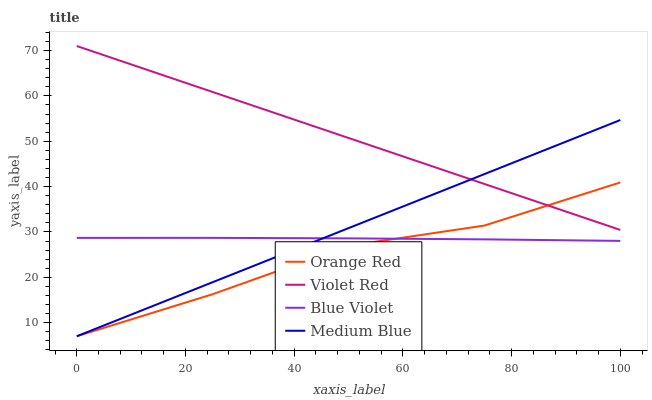Does Orange Red have the minimum area under the curve?
Answer yes or no. Yes. Does Violet Red have the maximum area under the curve?
Answer yes or no. Yes. Does Medium Blue have the minimum area under the curve?
Answer yes or no. No. Does Medium Blue have the maximum area under the curve?
Answer yes or no. No. Is Medium Blue the smoothest?
Answer yes or no. Yes. Is Orange Red the roughest?
Answer yes or no. Yes. Is Orange Red the smoothest?
Answer yes or no. No. Is Medium Blue the roughest?
Answer yes or no. No. Does Medium Blue have the lowest value?
Answer yes or no. Yes. Does Blue Violet have the lowest value?
Answer yes or no. No. Does Violet Red have the highest value?
Answer yes or no. Yes. Does Medium Blue have the highest value?
Answer yes or no. No. Is Blue Violet less than Violet Red?
Answer yes or no. Yes. Is Violet Red greater than Blue Violet?
Answer yes or no. Yes. Does Blue Violet intersect Medium Blue?
Answer yes or no. Yes. Is Blue Violet less than Medium Blue?
Answer yes or no. No. Is Blue Violet greater than Medium Blue?
Answer yes or no. No. Does Blue Violet intersect Violet Red?
Answer yes or no. No. 